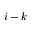Convert formula to latex. <formula><loc_0><loc_0><loc_500><loc_500>i - k</formula> 